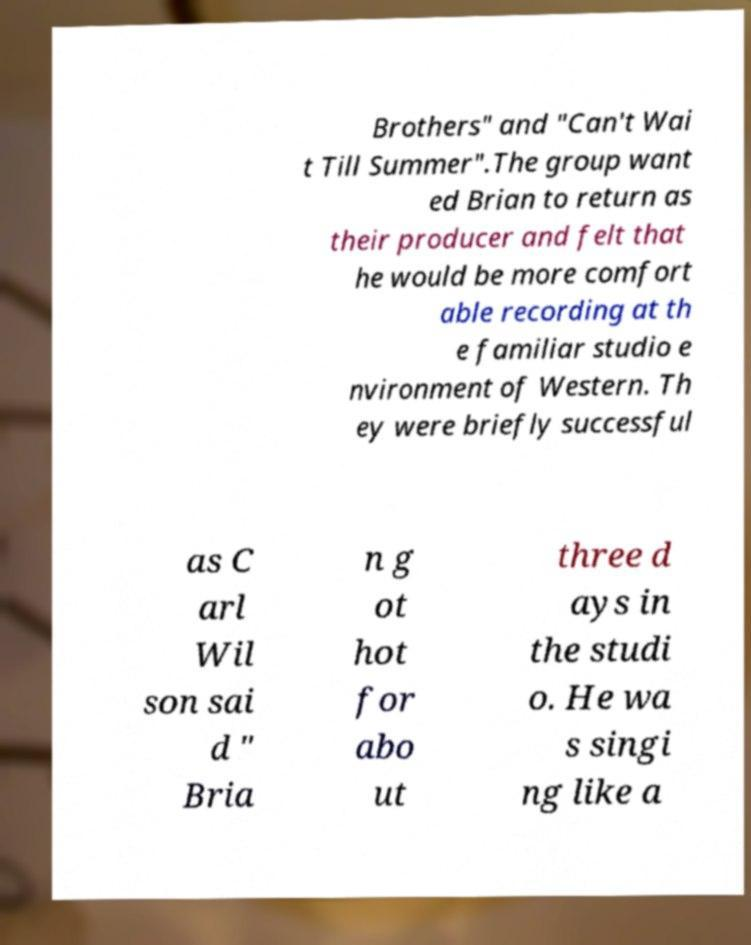Could you extract and type out the text from this image? Brothers" and "Can't Wai t Till Summer".The group want ed Brian to return as their producer and felt that he would be more comfort able recording at th e familiar studio e nvironment of Western. Th ey were briefly successful as C arl Wil son sai d " Bria n g ot hot for abo ut three d ays in the studi o. He wa s singi ng like a 